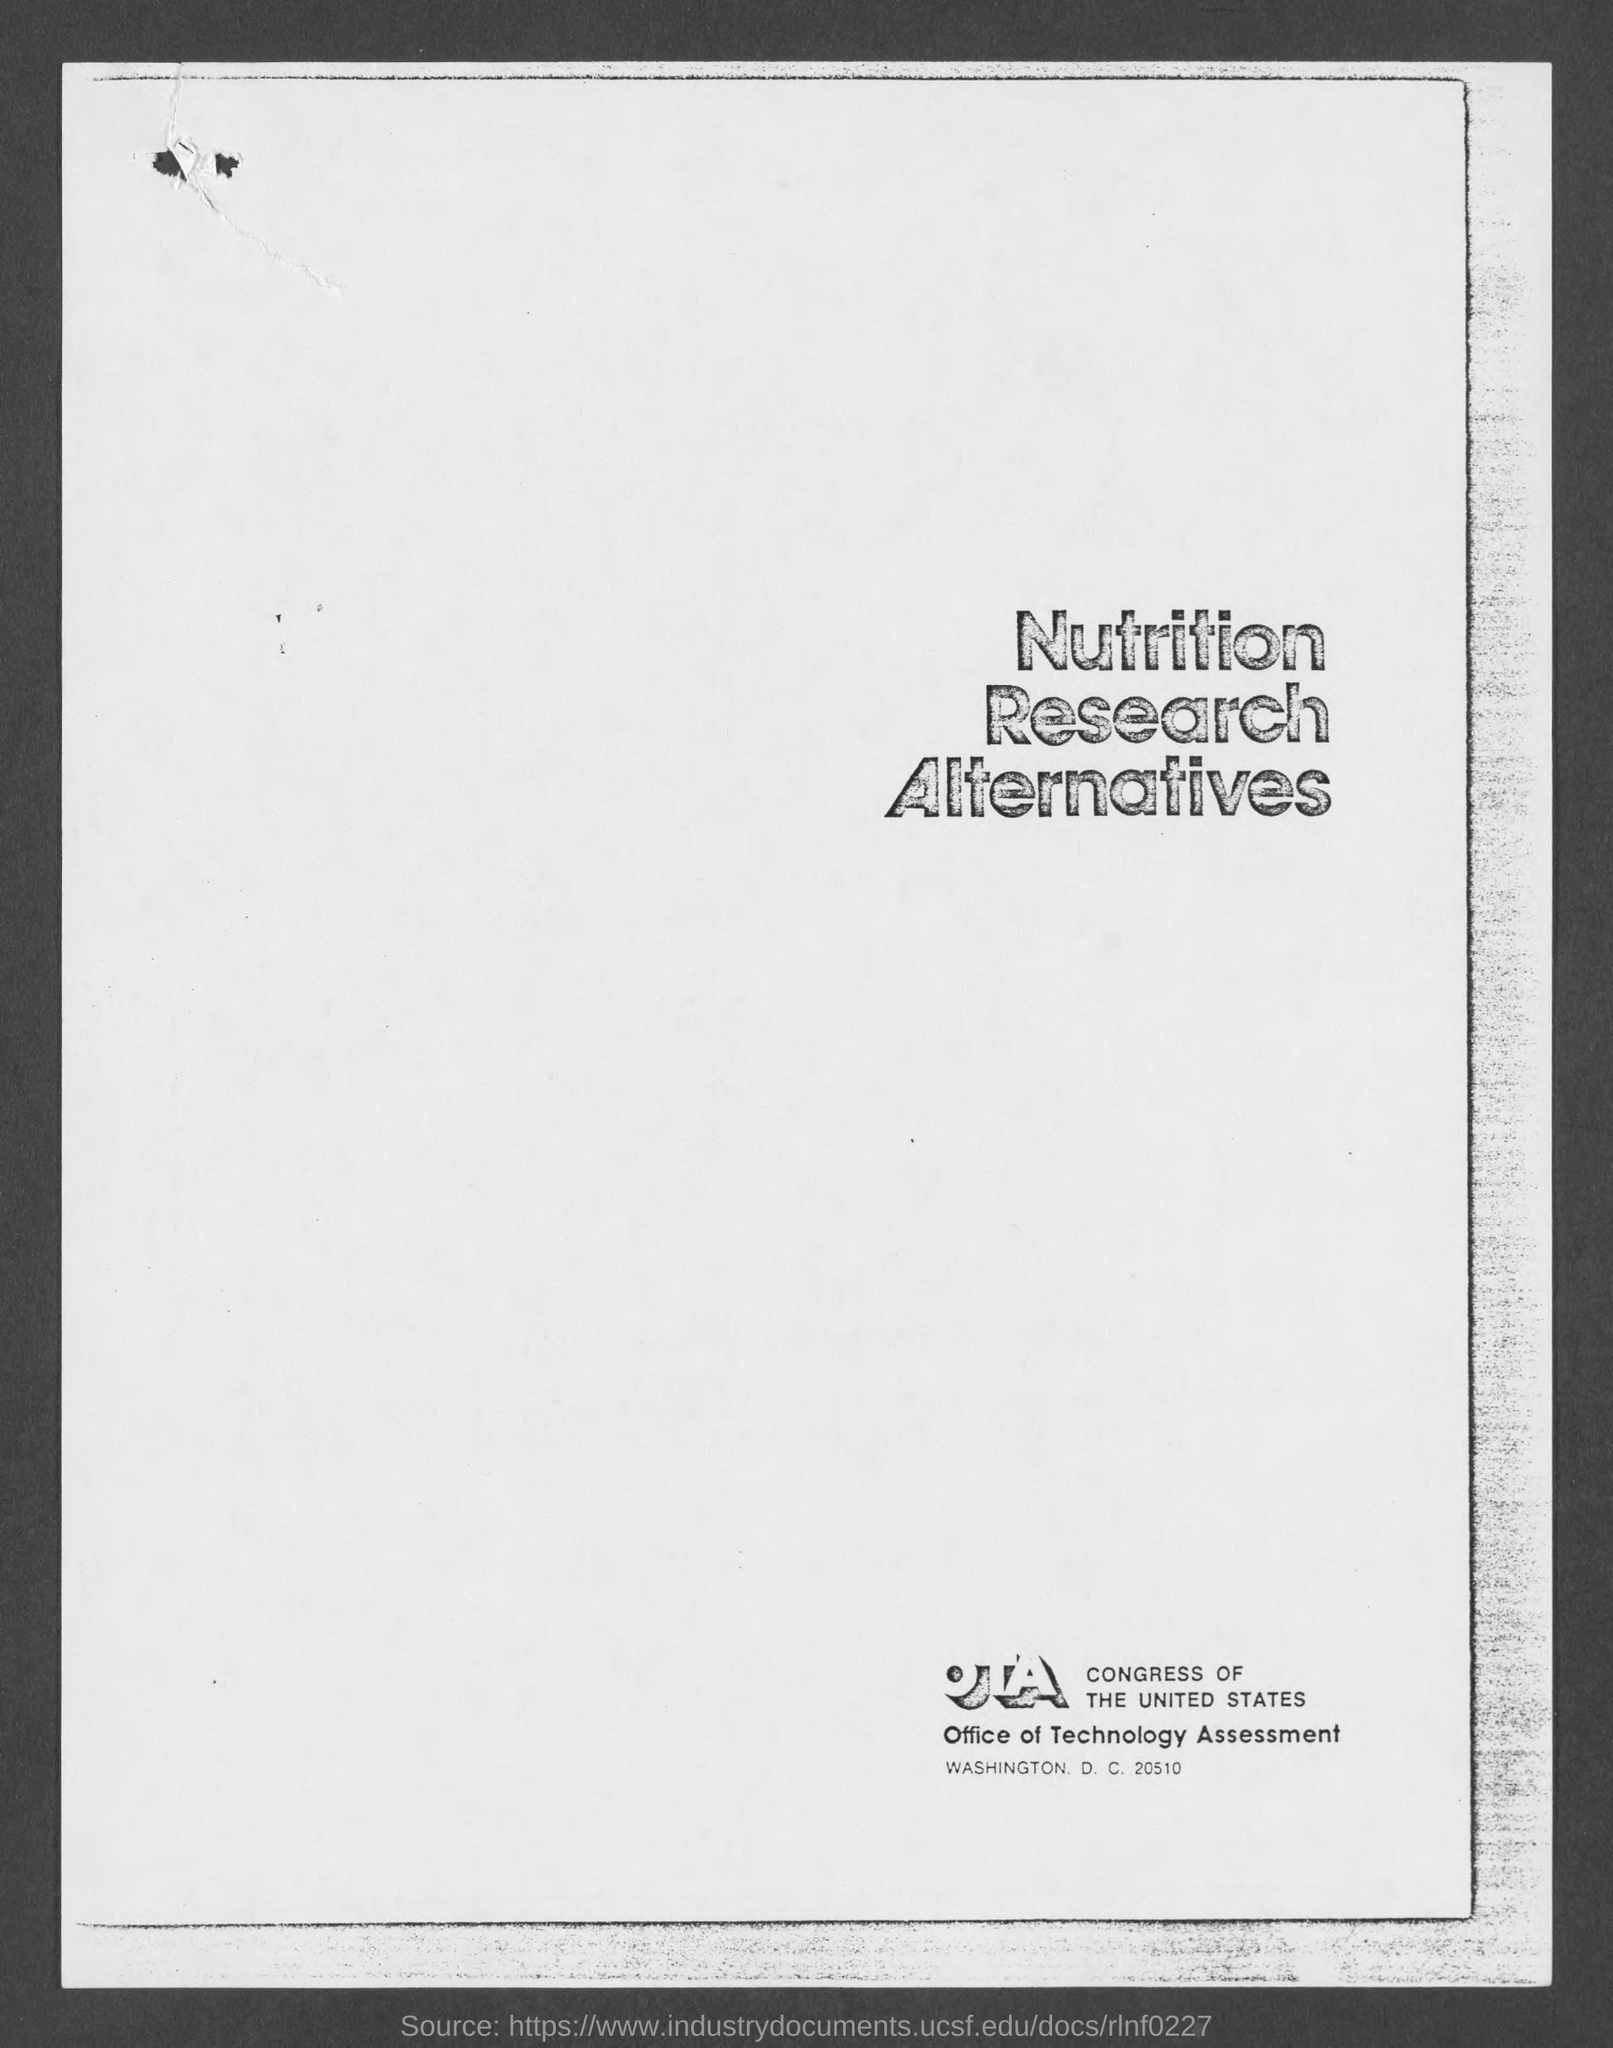What is the title of the document?
Make the answer very short. Nutrition Research Alternatives. What is the full form of OTA?
Provide a short and direct response. Office of Technology Assessment. 